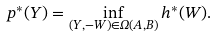<formula> <loc_0><loc_0><loc_500><loc_500>p ^ { * } ( Y ) = \inf _ { ( Y , - W ) \in \Omega ( A , B ) } h ^ { * } ( W ) .</formula> 